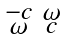Convert formula to latex. <formula><loc_0><loc_0><loc_500><loc_500>\begin{smallmatrix} - c & \omega \\ \omega & c \end{smallmatrix}</formula> 